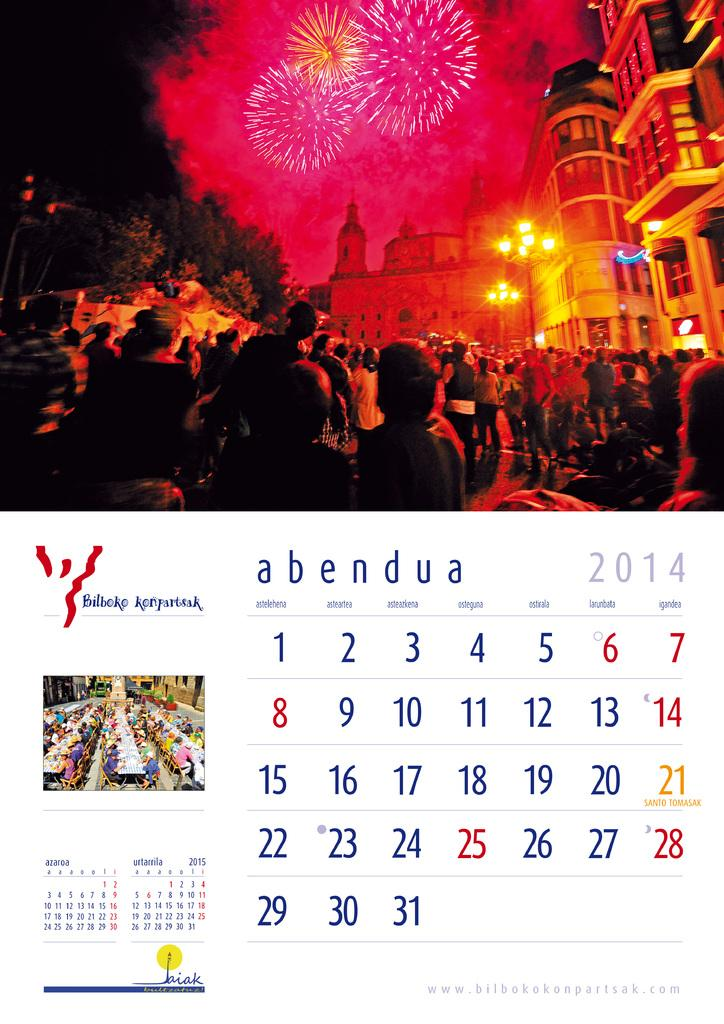How many people are in the group visible in the image? There is a group of people in the image, but the exact number cannot be determined from the provided facts. What type of structures can be seen in the image? There are buildings in the image. What other natural elements are present in the image? There are trees in the image. What type of illumination is present in the image? There are lights in the image. What additional visual effects can be observed in the image? There are sparkles in the image. What object is located at the bottom of the image? There is a calendar at the bottom of the image. What type of steel is used to construct the buildings in the image? There is no information about the type of steel used to construct the buildings in the image. How many brothers are present in the group of people in the image? The provided facts do not mention any brothers in the group of people, so we cannot determine their number. 